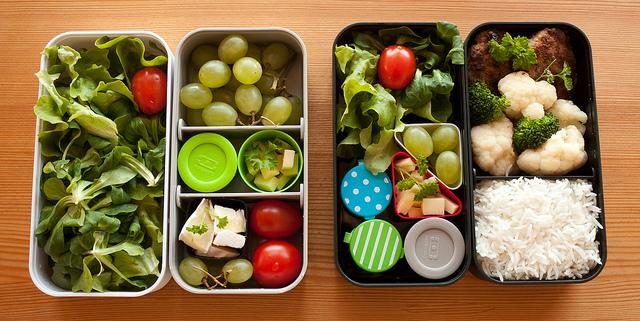Would you eat this?
Write a very short answer. Yes. How many kids are there?
Short answer required. 0. What kind of food can be seen?
Be succinct. Fruit and vegetables. 